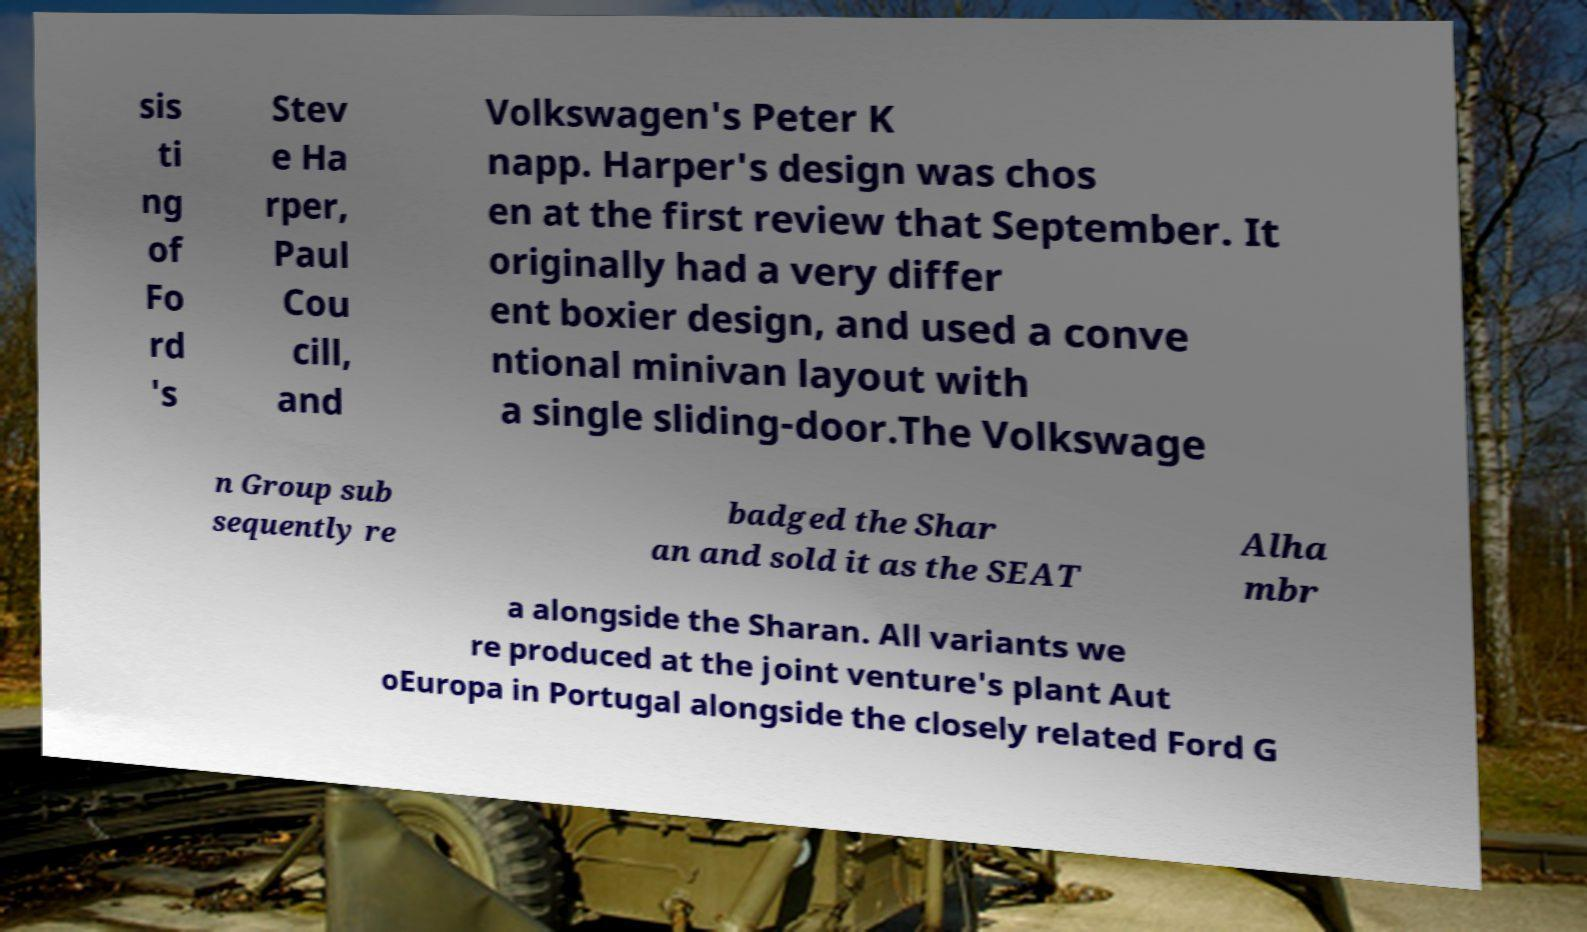Can you read and provide the text displayed in the image?This photo seems to have some interesting text. Can you extract and type it out for me? sis ti ng of Fo rd 's Stev e Ha rper, Paul Cou cill, and Volkswagen's Peter K napp. Harper's design was chos en at the first review that September. It originally had a very differ ent boxier design, and used a conve ntional minivan layout with a single sliding-door.The Volkswage n Group sub sequently re badged the Shar an and sold it as the SEAT Alha mbr a alongside the Sharan. All variants we re produced at the joint venture's plant Aut oEuropa in Portugal alongside the closely related Ford G 